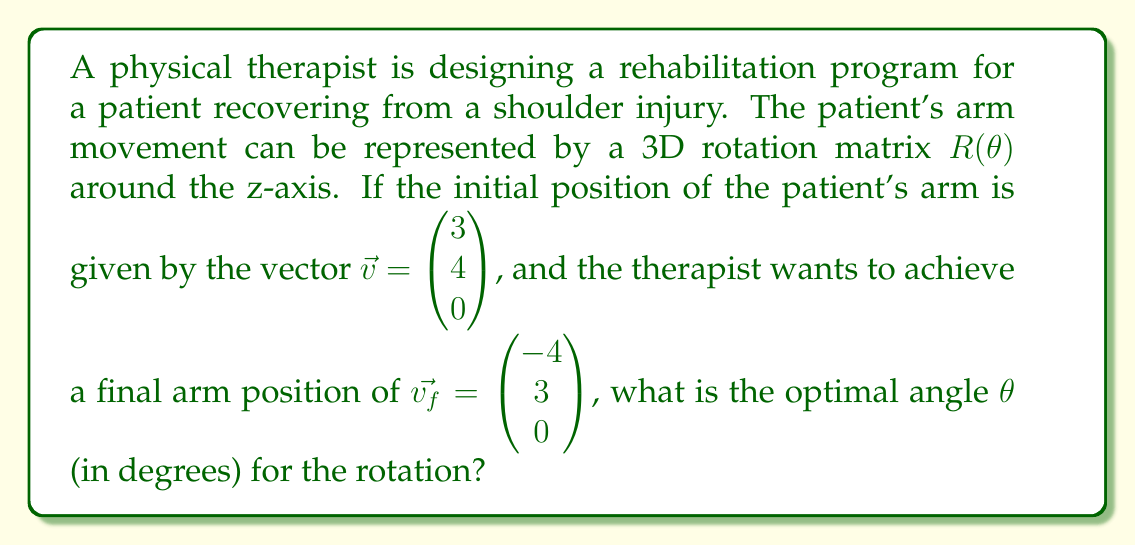Can you answer this question? Let's approach this step-by-step:

1) The 3D rotation matrix around the z-axis is given by:

   $$R(\theta) = \begin{pmatrix}
   \cos\theta & -\sin\theta & 0 \\
   \sin\theta & \cos\theta & 0 \\
   0 & 0 & 1
   \end{pmatrix}$$

2) We need to find $\theta$ such that $R(\theta)\vec{v} = \vec{v_f}$

3) Let's multiply these matrices:

   $$\begin{pmatrix}
   \cos\theta & -\sin\theta & 0 \\
   \sin\theta & \cos\theta & 0 \\
   0 & 0 & 1
   \end{pmatrix}
   \begin{pmatrix}
   3 \\
   4 \\
   0
   \end{pmatrix} =
   \begin{pmatrix}
   -4 \\
   3 \\
   0
   \end{pmatrix}$$

4) This gives us two equations:
   
   $3\cos\theta - 4\sin\theta = -4$
   $3\sin\theta + 4\cos\theta = 3$

5) We can solve this using the arctangent function. Dividing the second equation by the first:

   $\frac{3\sin\theta + 4\cos\theta}{3\cos\theta - 4\sin\theta} = \frac{3}{-4}$

6) This simplifies to:

   $\tan(\theta + \arctan(\frac{4}{3})) = -\frac{3}{4}$

7) Solving for $\theta$:

   $\theta = \arctan(-\frac{3}{4}) - \arctan(\frac{4}{3})$

8) Converting to degrees:

   $\theta = (\arctan(-\frac{3}{4}) - \arctan(\frac{4}{3})) \cdot \frac{180}{\pi} \approx -90°$

9) We can confirm this result by plugging it back into the rotation matrix.
Answer: $-90°$ 